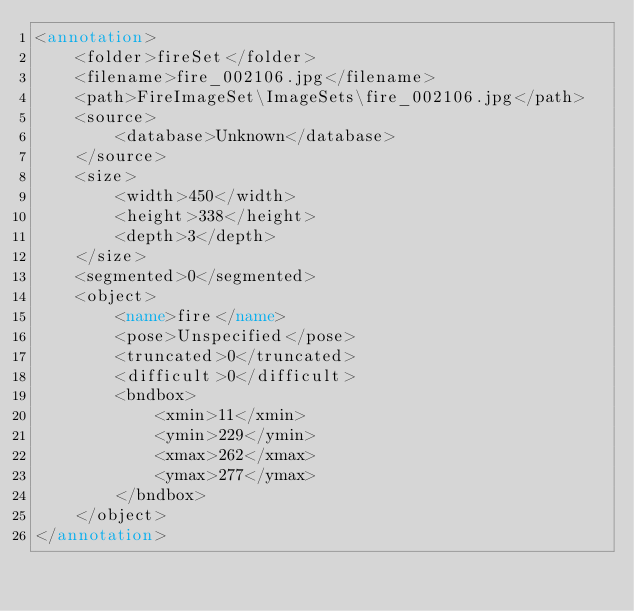Convert code to text. <code><loc_0><loc_0><loc_500><loc_500><_XML_><annotation>
	<folder>fireSet</folder>
	<filename>fire_002106.jpg</filename>
	<path>FireImageSet\ImageSets\fire_002106.jpg</path>
	<source>
		<database>Unknown</database>
	</source>
	<size>
		<width>450</width>
		<height>338</height>
		<depth>3</depth>
	</size>
	<segmented>0</segmented>
	<object>
		<name>fire</name>
		<pose>Unspecified</pose>
		<truncated>0</truncated>
		<difficult>0</difficult>
		<bndbox>
			<xmin>11</xmin>
			<ymin>229</ymin>
			<xmax>262</xmax>
			<ymax>277</ymax>
		</bndbox>
	</object>
</annotation></code> 